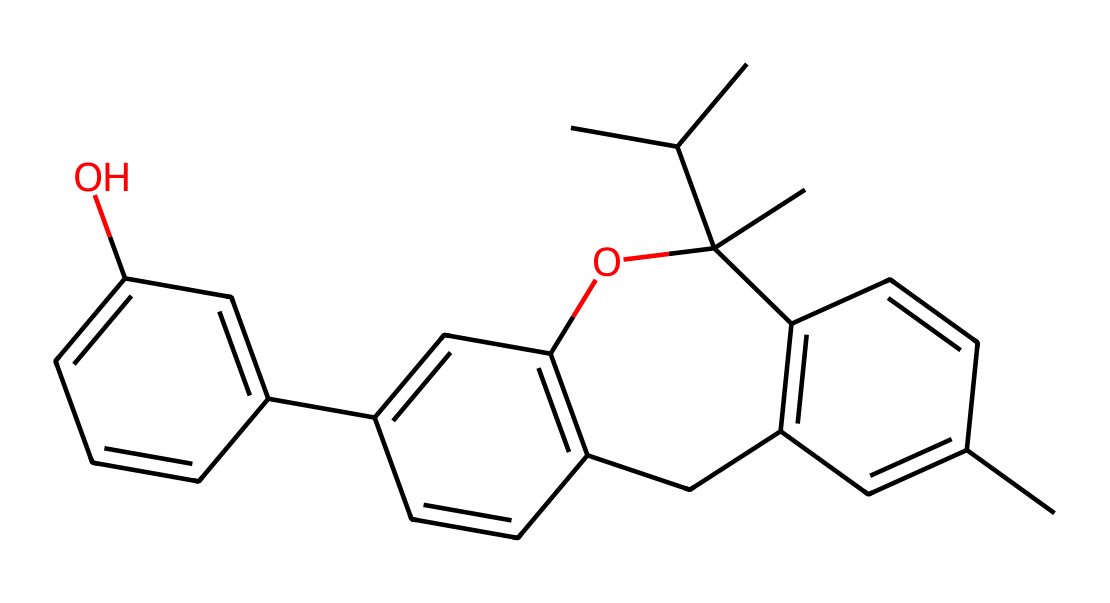how many carbon atoms are in this structure? Counting the carbon atoms in the SMILES representation, we find 21 carbon atoms present in the structure of THC.
Answer: 21 what is the molecular weight of THC? By calculating based on the atom counts from the structural formula, the molecular weight of THC is approximately 314.47 g/mol.
Answer: 314.47 what functional group is present in THC? The structure exhibits a phenolic hydroxyl group (-OH) due to the presence of the -OH bond on one of the benzene-like rings, indicating the presence of a phenolic functional group.
Answer: phenolic which part of THC interacts with cannabinoid receptors? The aromatic ring systems within the THC structure fit into cannabinoid receptors, allowing interaction, particularly at the C6-C7 bond.
Answer: aromatic ring how many double bonds are present in THC? Upon analyzing the structure, it is apparent that THC has 5 double bonds, as indicated by the connections between the carbon atoms in the rings and chains.
Answer: 5 what is the primary effect of THC on the human body? THC primarily acts as a psychoactive compound, leading to euphoria and altered perceptions, affecting the central nervous system.
Answer: psychoactive what type of compound is THC? THC is classified as a cannabinoid, derived from the Cannabis plant, which is characterized by its interaction with the endocannabinoid system.
Answer: cannabinoid 